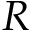Convert formula to latex. <formula><loc_0><loc_0><loc_500><loc_500>R</formula> 